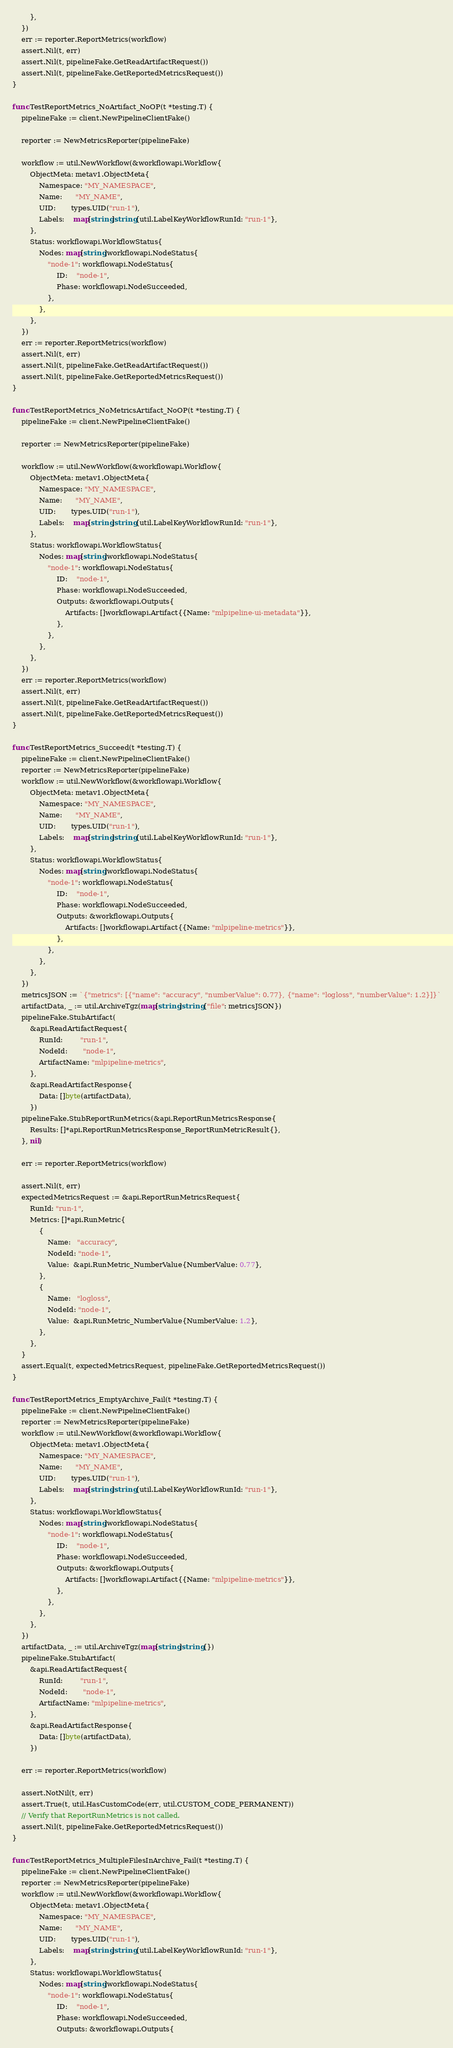<code> <loc_0><loc_0><loc_500><loc_500><_Go_>		},
	})
	err := reporter.ReportMetrics(workflow)
	assert.Nil(t, err)
	assert.Nil(t, pipelineFake.GetReadArtifactRequest())
	assert.Nil(t, pipelineFake.GetReportedMetricsRequest())
}

func TestReportMetrics_NoArtifact_NoOP(t *testing.T) {
	pipelineFake := client.NewPipelineClientFake()

	reporter := NewMetricsReporter(pipelineFake)

	workflow := util.NewWorkflow(&workflowapi.Workflow{
		ObjectMeta: metav1.ObjectMeta{
			Namespace: "MY_NAMESPACE",
			Name:      "MY_NAME",
			UID:       types.UID("run-1"),
			Labels:    map[string]string{util.LabelKeyWorkflowRunId: "run-1"},
		},
		Status: workflowapi.WorkflowStatus{
			Nodes: map[string]workflowapi.NodeStatus{
				"node-1": workflowapi.NodeStatus{
					ID:    "node-1",
					Phase: workflowapi.NodeSucceeded,
				},
			},
		},
	})
	err := reporter.ReportMetrics(workflow)
	assert.Nil(t, err)
	assert.Nil(t, pipelineFake.GetReadArtifactRequest())
	assert.Nil(t, pipelineFake.GetReportedMetricsRequest())
}

func TestReportMetrics_NoMetricsArtifact_NoOP(t *testing.T) {
	pipelineFake := client.NewPipelineClientFake()

	reporter := NewMetricsReporter(pipelineFake)

	workflow := util.NewWorkflow(&workflowapi.Workflow{
		ObjectMeta: metav1.ObjectMeta{
			Namespace: "MY_NAMESPACE",
			Name:      "MY_NAME",
			UID:       types.UID("run-1"),
			Labels:    map[string]string{util.LabelKeyWorkflowRunId: "run-1"},
		},
		Status: workflowapi.WorkflowStatus{
			Nodes: map[string]workflowapi.NodeStatus{
				"node-1": workflowapi.NodeStatus{
					ID:    "node-1",
					Phase: workflowapi.NodeSucceeded,
					Outputs: &workflowapi.Outputs{
						Artifacts: []workflowapi.Artifact{{Name: "mlpipeline-ui-metadata"}},
					},
				},
			},
		},
	})
	err := reporter.ReportMetrics(workflow)
	assert.Nil(t, err)
	assert.Nil(t, pipelineFake.GetReadArtifactRequest())
	assert.Nil(t, pipelineFake.GetReportedMetricsRequest())
}

func TestReportMetrics_Succeed(t *testing.T) {
	pipelineFake := client.NewPipelineClientFake()
	reporter := NewMetricsReporter(pipelineFake)
	workflow := util.NewWorkflow(&workflowapi.Workflow{
		ObjectMeta: metav1.ObjectMeta{
			Namespace: "MY_NAMESPACE",
			Name:      "MY_NAME",
			UID:       types.UID("run-1"),
			Labels:    map[string]string{util.LabelKeyWorkflowRunId: "run-1"},
		},
		Status: workflowapi.WorkflowStatus{
			Nodes: map[string]workflowapi.NodeStatus{
				"node-1": workflowapi.NodeStatus{
					ID:    "node-1",
					Phase: workflowapi.NodeSucceeded,
					Outputs: &workflowapi.Outputs{
						Artifacts: []workflowapi.Artifact{{Name: "mlpipeline-metrics"}},
					},
				},
			},
		},
	})
	metricsJSON := `{"metrics": [{"name": "accuracy", "numberValue": 0.77}, {"name": "logloss", "numberValue": 1.2}]}`
	artifactData, _ := util.ArchiveTgz(map[string]string{"file": metricsJSON})
	pipelineFake.StubArtifact(
		&api.ReadArtifactRequest{
			RunId:        "run-1",
			NodeId:       "node-1",
			ArtifactName: "mlpipeline-metrics",
		},
		&api.ReadArtifactResponse{
			Data: []byte(artifactData),
		})
	pipelineFake.StubReportRunMetrics(&api.ReportRunMetricsResponse{
		Results: []*api.ReportRunMetricsResponse_ReportRunMetricResult{},
	}, nil)

	err := reporter.ReportMetrics(workflow)

	assert.Nil(t, err)
	expectedMetricsRequest := &api.ReportRunMetricsRequest{
		RunId: "run-1",
		Metrics: []*api.RunMetric{
			{
				Name:   "accuracy",
				NodeId: "node-1",
				Value:  &api.RunMetric_NumberValue{NumberValue: 0.77},
			},
			{
				Name:   "logloss",
				NodeId: "node-1",
				Value:  &api.RunMetric_NumberValue{NumberValue: 1.2},
			},
		},
	}
	assert.Equal(t, expectedMetricsRequest, pipelineFake.GetReportedMetricsRequest())
}

func TestReportMetrics_EmptyArchive_Fail(t *testing.T) {
	pipelineFake := client.NewPipelineClientFake()
	reporter := NewMetricsReporter(pipelineFake)
	workflow := util.NewWorkflow(&workflowapi.Workflow{
		ObjectMeta: metav1.ObjectMeta{
			Namespace: "MY_NAMESPACE",
			Name:      "MY_NAME",
			UID:       types.UID("run-1"),
			Labels:    map[string]string{util.LabelKeyWorkflowRunId: "run-1"},
		},
		Status: workflowapi.WorkflowStatus{
			Nodes: map[string]workflowapi.NodeStatus{
				"node-1": workflowapi.NodeStatus{
					ID:    "node-1",
					Phase: workflowapi.NodeSucceeded,
					Outputs: &workflowapi.Outputs{
						Artifacts: []workflowapi.Artifact{{Name: "mlpipeline-metrics"}},
					},
				},
			},
		},
	})
	artifactData, _ := util.ArchiveTgz(map[string]string{})
	pipelineFake.StubArtifact(
		&api.ReadArtifactRequest{
			RunId:        "run-1",
			NodeId:       "node-1",
			ArtifactName: "mlpipeline-metrics",
		},
		&api.ReadArtifactResponse{
			Data: []byte(artifactData),
		})

	err := reporter.ReportMetrics(workflow)

	assert.NotNil(t, err)
	assert.True(t, util.HasCustomCode(err, util.CUSTOM_CODE_PERMANENT))
	// Verify that ReportRunMetrics is not called.
	assert.Nil(t, pipelineFake.GetReportedMetricsRequest())
}

func TestReportMetrics_MultipleFilesInArchive_Fail(t *testing.T) {
	pipelineFake := client.NewPipelineClientFake()
	reporter := NewMetricsReporter(pipelineFake)
	workflow := util.NewWorkflow(&workflowapi.Workflow{
		ObjectMeta: metav1.ObjectMeta{
			Namespace: "MY_NAMESPACE",
			Name:      "MY_NAME",
			UID:       types.UID("run-1"),
			Labels:    map[string]string{util.LabelKeyWorkflowRunId: "run-1"},
		},
		Status: workflowapi.WorkflowStatus{
			Nodes: map[string]workflowapi.NodeStatus{
				"node-1": workflowapi.NodeStatus{
					ID:    "node-1",
					Phase: workflowapi.NodeSucceeded,
					Outputs: &workflowapi.Outputs{</code> 